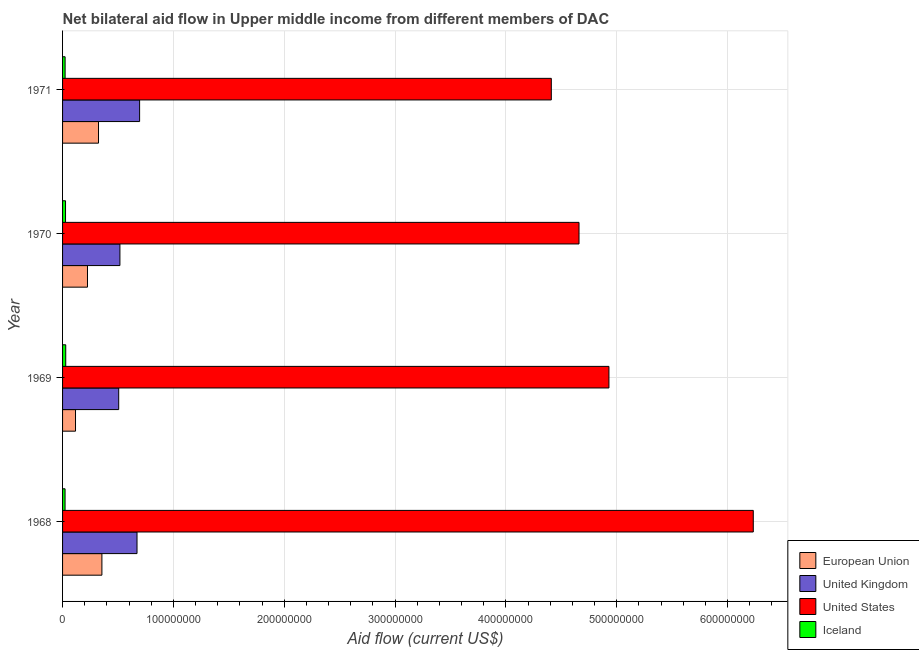How many groups of bars are there?
Your answer should be compact. 4. Are the number of bars per tick equal to the number of legend labels?
Your response must be concise. Yes. In how many cases, is the number of bars for a given year not equal to the number of legend labels?
Your answer should be very brief. 0. What is the amount of aid given by iceland in 1970?
Your answer should be compact. 2.68e+06. Across all years, what is the maximum amount of aid given by us?
Provide a short and direct response. 6.23e+08. Across all years, what is the minimum amount of aid given by uk?
Ensure brevity in your answer.  5.07e+07. In which year was the amount of aid given by uk maximum?
Provide a succinct answer. 1971. In which year was the amount of aid given by uk minimum?
Your answer should be compact. 1969. What is the total amount of aid given by us in the graph?
Your answer should be very brief. 2.02e+09. What is the difference between the amount of aid given by us in 1968 and that in 1970?
Offer a terse response. 1.57e+08. What is the difference between the amount of aid given by eu in 1970 and the amount of aid given by uk in 1971?
Give a very brief answer. -4.70e+07. What is the average amount of aid given by uk per year?
Provide a succinct answer. 5.98e+07. In the year 1968, what is the difference between the amount of aid given by eu and amount of aid given by uk?
Provide a short and direct response. -3.17e+07. What is the ratio of the amount of aid given by us in 1968 to that in 1969?
Ensure brevity in your answer.  1.26. Is the amount of aid given by eu in 1968 less than that in 1970?
Provide a short and direct response. No. What is the difference between the highest and the second highest amount of aid given by us?
Offer a terse response. 1.30e+08. What is the difference between the highest and the lowest amount of aid given by iceland?
Your answer should be very brief. 6.10e+05. Is the sum of the amount of aid given by uk in 1968 and 1969 greater than the maximum amount of aid given by iceland across all years?
Make the answer very short. Yes. What does the 4th bar from the bottom in 1968 represents?
Offer a very short reply. Iceland. Is it the case that in every year, the sum of the amount of aid given by eu and amount of aid given by uk is greater than the amount of aid given by us?
Offer a very short reply. No. How many bars are there?
Ensure brevity in your answer.  16. Are all the bars in the graph horizontal?
Make the answer very short. Yes. Are the values on the major ticks of X-axis written in scientific E-notation?
Provide a short and direct response. No. What is the title of the graph?
Keep it short and to the point. Net bilateral aid flow in Upper middle income from different members of DAC. Does "Offering training" appear as one of the legend labels in the graph?
Make the answer very short. No. What is the label or title of the X-axis?
Keep it short and to the point. Aid flow (current US$). What is the label or title of the Y-axis?
Offer a very short reply. Year. What is the Aid flow (current US$) in European Union in 1968?
Give a very brief answer. 3.55e+07. What is the Aid flow (current US$) in United Kingdom in 1968?
Make the answer very short. 6.72e+07. What is the Aid flow (current US$) in United States in 1968?
Provide a succinct answer. 6.23e+08. What is the Aid flow (current US$) of Iceland in 1968?
Give a very brief answer. 2.25e+06. What is the Aid flow (current US$) in European Union in 1969?
Ensure brevity in your answer.  1.17e+07. What is the Aid flow (current US$) of United Kingdom in 1969?
Your answer should be compact. 5.07e+07. What is the Aid flow (current US$) in United States in 1969?
Your answer should be compact. 4.93e+08. What is the Aid flow (current US$) of Iceland in 1969?
Your response must be concise. 2.86e+06. What is the Aid flow (current US$) of European Union in 1970?
Your answer should be compact. 2.25e+07. What is the Aid flow (current US$) of United Kingdom in 1970?
Provide a succinct answer. 5.18e+07. What is the Aid flow (current US$) in United States in 1970?
Provide a succinct answer. 4.66e+08. What is the Aid flow (current US$) of Iceland in 1970?
Keep it short and to the point. 2.68e+06. What is the Aid flow (current US$) of European Union in 1971?
Give a very brief answer. 3.24e+07. What is the Aid flow (current US$) in United Kingdom in 1971?
Ensure brevity in your answer.  6.95e+07. What is the Aid flow (current US$) in United States in 1971?
Your response must be concise. 4.41e+08. What is the Aid flow (current US$) of Iceland in 1971?
Your answer should be very brief. 2.30e+06. Across all years, what is the maximum Aid flow (current US$) of European Union?
Ensure brevity in your answer.  3.55e+07. Across all years, what is the maximum Aid flow (current US$) in United Kingdom?
Your answer should be very brief. 6.95e+07. Across all years, what is the maximum Aid flow (current US$) in United States?
Your answer should be very brief. 6.23e+08. Across all years, what is the maximum Aid flow (current US$) of Iceland?
Make the answer very short. 2.86e+06. Across all years, what is the minimum Aid flow (current US$) in European Union?
Offer a terse response. 1.17e+07. Across all years, what is the minimum Aid flow (current US$) of United Kingdom?
Provide a succinct answer. 5.07e+07. Across all years, what is the minimum Aid flow (current US$) of United States?
Ensure brevity in your answer.  4.41e+08. Across all years, what is the minimum Aid flow (current US$) of Iceland?
Provide a short and direct response. 2.25e+06. What is the total Aid flow (current US$) in European Union in the graph?
Offer a terse response. 1.02e+08. What is the total Aid flow (current US$) of United Kingdom in the graph?
Make the answer very short. 2.39e+08. What is the total Aid flow (current US$) in United States in the graph?
Provide a succinct answer. 2.02e+09. What is the total Aid flow (current US$) in Iceland in the graph?
Your answer should be very brief. 1.01e+07. What is the difference between the Aid flow (current US$) of European Union in 1968 and that in 1969?
Make the answer very short. 2.38e+07. What is the difference between the Aid flow (current US$) in United Kingdom in 1968 and that in 1969?
Offer a terse response. 1.65e+07. What is the difference between the Aid flow (current US$) of United States in 1968 and that in 1969?
Offer a terse response. 1.30e+08. What is the difference between the Aid flow (current US$) in Iceland in 1968 and that in 1969?
Offer a very short reply. -6.10e+05. What is the difference between the Aid flow (current US$) of European Union in 1968 and that in 1970?
Your answer should be very brief. 1.30e+07. What is the difference between the Aid flow (current US$) in United Kingdom in 1968 and that in 1970?
Provide a short and direct response. 1.54e+07. What is the difference between the Aid flow (current US$) of United States in 1968 and that in 1970?
Provide a succinct answer. 1.57e+08. What is the difference between the Aid flow (current US$) in Iceland in 1968 and that in 1970?
Your answer should be compact. -4.30e+05. What is the difference between the Aid flow (current US$) in European Union in 1968 and that in 1971?
Offer a terse response. 3.06e+06. What is the difference between the Aid flow (current US$) of United Kingdom in 1968 and that in 1971?
Your response must be concise. -2.33e+06. What is the difference between the Aid flow (current US$) in United States in 1968 and that in 1971?
Offer a very short reply. 1.82e+08. What is the difference between the Aid flow (current US$) in European Union in 1969 and that in 1970?
Your answer should be compact. -1.08e+07. What is the difference between the Aid flow (current US$) of United Kingdom in 1969 and that in 1970?
Your response must be concise. -1.09e+06. What is the difference between the Aid flow (current US$) of United States in 1969 and that in 1970?
Offer a terse response. 2.70e+07. What is the difference between the Aid flow (current US$) in European Union in 1969 and that in 1971?
Your answer should be compact. -2.08e+07. What is the difference between the Aid flow (current US$) in United Kingdom in 1969 and that in 1971?
Provide a short and direct response. -1.88e+07. What is the difference between the Aid flow (current US$) in United States in 1969 and that in 1971?
Offer a terse response. 5.20e+07. What is the difference between the Aid flow (current US$) of Iceland in 1969 and that in 1971?
Keep it short and to the point. 5.60e+05. What is the difference between the Aid flow (current US$) of European Union in 1970 and that in 1971?
Provide a succinct answer. -9.96e+06. What is the difference between the Aid flow (current US$) in United Kingdom in 1970 and that in 1971?
Make the answer very short. -1.78e+07. What is the difference between the Aid flow (current US$) of United States in 1970 and that in 1971?
Offer a terse response. 2.50e+07. What is the difference between the Aid flow (current US$) of European Union in 1968 and the Aid flow (current US$) of United Kingdom in 1969?
Your response must be concise. -1.52e+07. What is the difference between the Aid flow (current US$) of European Union in 1968 and the Aid flow (current US$) of United States in 1969?
Give a very brief answer. -4.58e+08. What is the difference between the Aid flow (current US$) in European Union in 1968 and the Aid flow (current US$) in Iceland in 1969?
Your answer should be very brief. 3.26e+07. What is the difference between the Aid flow (current US$) in United Kingdom in 1968 and the Aid flow (current US$) in United States in 1969?
Offer a very short reply. -4.26e+08. What is the difference between the Aid flow (current US$) in United Kingdom in 1968 and the Aid flow (current US$) in Iceland in 1969?
Provide a succinct answer. 6.43e+07. What is the difference between the Aid flow (current US$) of United States in 1968 and the Aid flow (current US$) of Iceland in 1969?
Offer a very short reply. 6.20e+08. What is the difference between the Aid flow (current US$) of European Union in 1968 and the Aid flow (current US$) of United Kingdom in 1970?
Offer a terse response. -1.62e+07. What is the difference between the Aid flow (current US$) in European Union in 1968 and the Aid flow (current US$) in United States in 1970?
Your response must be concise. -4.30e+08. What is the difference between the Aid flow (current US$) in European Union in 1968 and the Aid flow (current US$) in Iceland in 1970?
Ensure brevity in your answer.  3.28e+07. What is the difference between the Aid flow (current US$) in United Kingdom in 1968 and the Aid flow (current US$) in United States in 1970?
Keep it short and to the point. -3.99e+08. What is the difference between the Aid flow (current US$) of United Kingdom in 1968 and the Aid flow (current US$) of Iceland in 1970?
Provide a short and direct response. 6.45e+07. What is the difference between the Aid flow (current US$) of United States in 1968 and the Aid flow (current US$) of Iceland in 1970?
Provide a short and direct response. 6.21e+08. What is the difference between the Aid flow (current US$) in European Union in 1968 and the Aid flow (current US$) in United Kingdom in 1971?
Provide a succinct answer. -3.40e+07. What is the difference between the Aid flow (current US$) in European Union in 1968 and the Aid flow (current US$) in United States in 1971?
Keep it short and to the point. -4.06e+08. What is the difference between the Aid flow (current US$) in European Union in 1968 and the Aid flow (current US$) in Iceland in 1971?
Keep it short and to the point. 3.32e+07. What is the difference between the Aid flow (current US$) in United Kingdom in 1968 and the Aid flow (current US$) in United States in 1971?
Provide a succinct answer. -3.74e+08. What is the difference between the Aid flow (current US$) of United Kingdom in 1968 and the Aid flow (current US$) of Iceland in 1971?
Your answer should be compact. 6.49e+07. What is the difference between the Aid flow (current US$) of United States in 1968 and the Aid flow (current US$) of Iceland in 1971?
Offer a terse response. 6.21e+08. What is the difference between the Aid flow (current US$) in European Union in 1969 and the Aid flow (current US$) in United Kingdom in 1970?
Keep it short and to the point. -4.01e+07. What is the difference between the Aid flow (current US$) of European Union in 1969 and the Aid flow (current US$) of United States in 1970?
Offer a very short reply. -4.54e+08. What is the difference between the Aid flow (current US$) in European Union in 1969 and the Aid flow (current US$) in Iceland in 1970?
Make the answer very short. 9.01e+06. What is the difference between the Aid flow (current US$) in United Kingdom in 1969 and the Aid flow (current US$) in United States in 1970?
Your answer should be compact. -4.15e+08. What is the difference between the Aid flow (current US$) of United Kingdom in 1969 and the Aid flow (current US$) of Iceland in 1970?
Your response must be concise. 4.80e+07. What is the difference between the Aid flow (current US$) in United States in 1969 and the Aid flow (current US$) in Iceland in 1970?
Give a very brief answer. 4.90e+08. What is the difference between the Aid flow (current US$) of European Union in 1969 and the Aid flow (current US$) of United Kingdom in 1971?
Ensure brevity in your answer.  -5.78e+07. What is the difference between the Aid flow (current US$) of European Union in 1969 and the Aid flow (current US$) of United States in 1971?
Your response must be concise. -4.29e+08. What is the difference between the Aid flow (current US$) of European Union in 1969 and the Aid flow (current US$) of Iceland in 1971?
Your response must be concise. 9.39e+06. What is the difference between the Aid flow (current US$) of United Kingdom in 1969 and the Aid flow (current US$) of United States in 1971?
Keep it short and to the point. -3.90e+08. What is the difference between the Aid flow (current US$) in United Kingdom in 1969 and the Aid flow (current US$) in Iceland in 1971?
Offer a very short reply. 4.84e+07. What is the difference between the Aid flow (current US$) of United States in 1969 and the Aid flow (current US$) of Iceland in 1971?
Provide a succinct answer. 4.91e+08. What is the difference between the Aid flow (current US$) in European Union in 1970 and the Aid flow (current US$) in United Kingdom in 1971?
Ensure brevity in your answer.  -4.70e+07. What is the difference between the Aid flow (current US$) of European Union in 1970 and the Aid flow (current US$) of United States in 1971?
Make the answer very short. -4.19e+08. What is the difference between the Aid flow (current US$) in European Union in 1970 and the Aid flow (current US$) in Iceland in 1971?
Your answer should be compact. 2.02e+07. What is the difference between the Aid flow (current US$) of United Kingdom in 1970 and the Aid flow (current US$) of United States in 1971?
Ensure brevity in your answer.  -3.89e+08. What is the difference between the Aid flow (current US$) of United Kingdom in 1970 and the Aid flow (current US$) of Iceland in 1971?
Your answer should be compact. 4.94e+07. What is the difference between the Aid flow (current US$) of United States in 1970 and the Aid flow (current US$) of Iceland in 1971?
Give a very brief answer. 4.64e+08. What is the average Aid flow (current US$) in European Union per year?
Make the answer very short. 2.55e+07. What is the average Aid flow (current US$) of United Kingdom per year?
Provide a succinct answer. 5.98e+07. What is the average Aid flow (current US$) in United States per year?
Make the answer very short. 5.06e+08. What is the average Aid flow (current US$) in Iceland per year?
Give a very brief answer. 2.52e+06. In the year 1968, what is the difference between the Aid flow (current US$) of European Union and Aid flow (current US$) of United Kingdom?
Give a very brief answer. -3.17e+07. In the year 1968, what is the difference between the Aid flow (current US$) of European Union and Aid flow (current US$) of United States?
Ensure brevity in your answer.  -5.88e+08. In the year 1968, what is the difference between the Aid flow (current US$) of European Union and Aid flow (current US$) of Iceland?
Offer a terse response. 3.32e+07. In the year 1968, what is the difference between the Aid flow (current US$) of United Kingdom and Aid flow (current US$) of United States?
Offer a very short reply. -5.56e+08. In the year 1968, what is the difference between the Aid flow (current US$) in United Kingdom and Aid flow (current US$) in Iceland?
Make the answer very short. 6.49e+07. In the year 1968, what is the difference between the Aid flow (current US$) in United States and Aid flow (current US$) in Iceland?
Make the answer very short. 6.21e+08. In the year 1969, what is the difference between the Aid flow (current US$) in European Union and Aid flow (current US$) in United Kingdom?
Ensure brevity in your answer.  -3.90e+07. In the year 1969, what is the difference between the Aid flow (current US$) in European Union and Aid flow (current US$) in United States?
Your answer should be compact. -4.81e+08. In the year 1969, what is the difference between the Aid flow (current US$) of European Union and Aid flow (current US$) of Iceland?
Offer a terse response. 8.83e+06. In the year 1969, what is the difference between the Aid flow (current US$) of United Kingdom and Aid flow (current US$) of United States?
Provide a short and direct response. -4.42e+08. In the year 1969, what is the difference between the Aid flow (current US$) of United Kingdom and Aid flow (current US$) of Iceland?
Provide a short and direct response. 4.78e+07. In the year 1969, what is the difference between the Aid flow (current US$) in United States and Aid flow (current US$) in Iceland?
Offer a terse response. 4.90e+08. In the year 1970, what is the difference between the Aid flow (current US$) of European Union and Aid flow (current US$) of United Kingdom?
Offer a very short reply. -2.93e+07. In the year 1970, what is the difference between the Aid flow (current US$) of European Union and Aid flow (current US$) of United States?
Make the answer very short. -4.44e+08. In the year 1970, what is the difference between the Aid flow (current US$) of European Union and Aid flow (current US$) of Iceland?
Provide a succinct answer. 1.98e+07. In the year 1970, what is the difference between the Aid flow (current US$) in United Kingdom and Aid flow (current US$) in United States?
Your answer should be very brief. -4.14e+08. In the year 1970, what is the difference between the Aid flow (current US$) of United Kingdom and Aid flow (current US$) of Iceland?
Your answer should be compact. 4.91e+07. In the year 1970, what is the difference between the Aid flow (current US$) of United States and Aid flow (current US$) of Iceland?
Make the answer very short. 4.63e+08. In the year 1971, what is the difference between the Aid flow (current US$) of European Union and Aid flow (current US$) of United Kingdom?
Make the answer very short. -3.71e+07. In the year 1971, what is the difference between the Aid flow (current US$) in European Union and Aid flow (current US$) in United States?
Give a very brief answer. -4.09e+08. In the year 1971, what is the difference between the Aid flow (current US$) of European Union and Aid flow (current US$) of Iceland?
Provide a succinct answer. 3.01e+07. In the year 1971, what is the difference between the Aid flow (current US$) in United Kingdom and Aid flow (current US$) in United States?
Give a very brief answer. -3.71e+08. In the year 1971, what is the difference between the Aid flow (current US$) in United Kingdom and Aid flow (current US$) in Iceland?
Make the answer very short. 6.72e+07. In the year 1971, what is the difference between the Aid flow (current US$) of United States and Aid flow (current US$) of Iceland?
Make the answer very short. 4.39e+08. What is the ratio of the Aid flow (current US$) of European Union in 1968 to that in 1969?
Your answer should be compact. 3.04. What is the ratio of the Aid flow (current US$) in United Kingdom in 1968 to that in 1969?
Your response must be concise. 1.33. What is the ratio of the Aid flow (current US$) in United States in 1968 to that in 1969?
Your response must be concise. 1.26. What is the ratio of the Aid flow (current US$) of Iceland in 1968 to that in 1969?
Provide a short and direct response. 0.79. What is the ratio of the Aid flow (current US$) of European Union in 1968 to that in 1970?
Offer a terse response. 1.58. What is the ratio of the Aid flow (current US$) in United Kingdom in 1968 to that in 1970?
Keep it short and to the point. 1.3. What is the ratio of the Aid flow (current US$) of United States in 1968 to that in 1970?
Make the answer very short. 1.34. What is the ratio of the Aid flow (current US$) of Iceland in 1968 to that in 1970?
Keep it short and to the point. 0.84. What is the ratio of the Aid flow (current US$) of European Union in 1968 to that in 1971?
Ensure brevity in your answer.  1.09. What is the ratio of the Aid flow (current US$) in United Kingdom in 1968 to that in 1971?
Your answer should be very brief. 0.97. What is the ratio of the Aid flow (current US$) of United States in 1968 to that in 1971?
Offer a terse response. 1.41. What is the ratio of the Aid flow (current US$) in Iceland in 1968 to that in 1971?
Your response must be concise. 0.98. What is the ratio of the Aid flow (current US$) in European Union in 1969 to that in 1970?
Your response must be concise. 0.52. What is the ratio of the Aid flow (current US$) in United Kingdom in 1969 to that in 1970?
Give a very brief answer. 0.98. What is the ratio of the Aid flow (current US$) of United States in 1969 to that in 1970?
Keep it short and to the point. 1.06. What is the ratio of the Aid flow (current US$) of Iceland in 1969 to that in 1970?
Offer a terse response. 1.07. What is the ratio of the Aid flow (current US$) in European Union in 1969 to that in 1971?
Keep it short and to the point. 0.36. What is the ratio of the Aid flow (current US$) of United Kingdom in 1969 to that in 1971?
Provide a succinct answer. 0.73. What is the ratio of the Aid flow (current US$) in United States in 1969 to that in 1971?
Give a very brief answer. 1.12. What is the ratio of the Aid flow (current US$) in Iceland in 1969 to that in 1971?
Provide a succinct answer. 1.24. What is the ratio of the Aid flow (current US$) of European Union in 1970 to that in 1971?
Offer a terse response. 0.69. What is the ratio of the Aid flow (current US$) in United Kingdom in 1970 to that in 1971?
Ensure brevity in your answer.  0.74. What is the ratio of the Aid flow (current US$) of United States in 1970 to that in 1971?
Keep it short and to the point. 1.06. What is the ratio of the Aid flow (current US$) in Iceland in 1970 to that in 1971?
Provide a succinct answer. 1.17. What is the difference between the highest and the second highest Aid flow (current US$) in European Union?
Your answer should be compact. 3.06e+06. What is the difference between the highest and the second highest Aid flow (current US$) of United Kingdom?
Your response must be concise. 2.33e+06. What is the difference between the highest and the second highest Aid flow (current US$) of United States?
Your answer should be compact. 1.30e+08. What is the difference between the highest and the second highest Aid flow (current US$) of Iceland?
Offer a very short reply. 1.80e+05. What is the difference between the highest and the lowest Aid flow (current US$) in European Union?
Your answer should be compact. 2.38e+07. What is the difference between the highest and the lowest Aid flow (current US$) of United Kingdom?
Provide a short and direct response. 1.88e+07. What is the difference between the highest and the lowest Aid flow (current US$) in United States?
Offer a very short reply. 1.82e+08. 